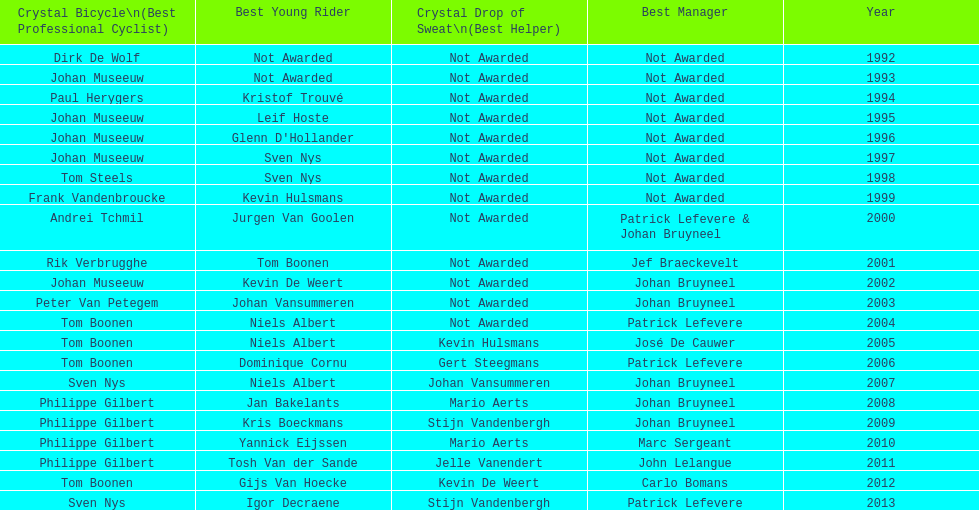How many times, on average, did johan museeuw appear as a star? 5. 